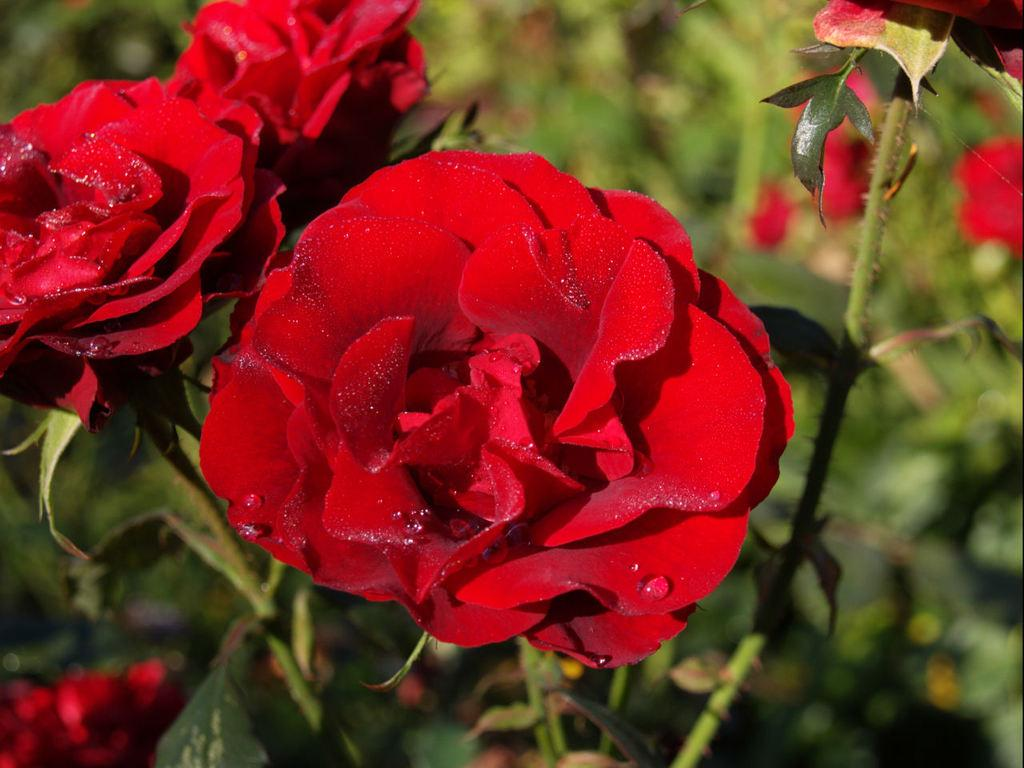What type of living organisms are in the image? There are plants in the image. What specific features can be observed on the plants? The plants have flowers and leaves. Can you describe the background of the image? The background of the image is blurry. What type of discussion is taking place in the image? There is no discussion present in the image; it features plants with flowers and leaves. Is there a rake visible in the image? There is no rake present in the image. 